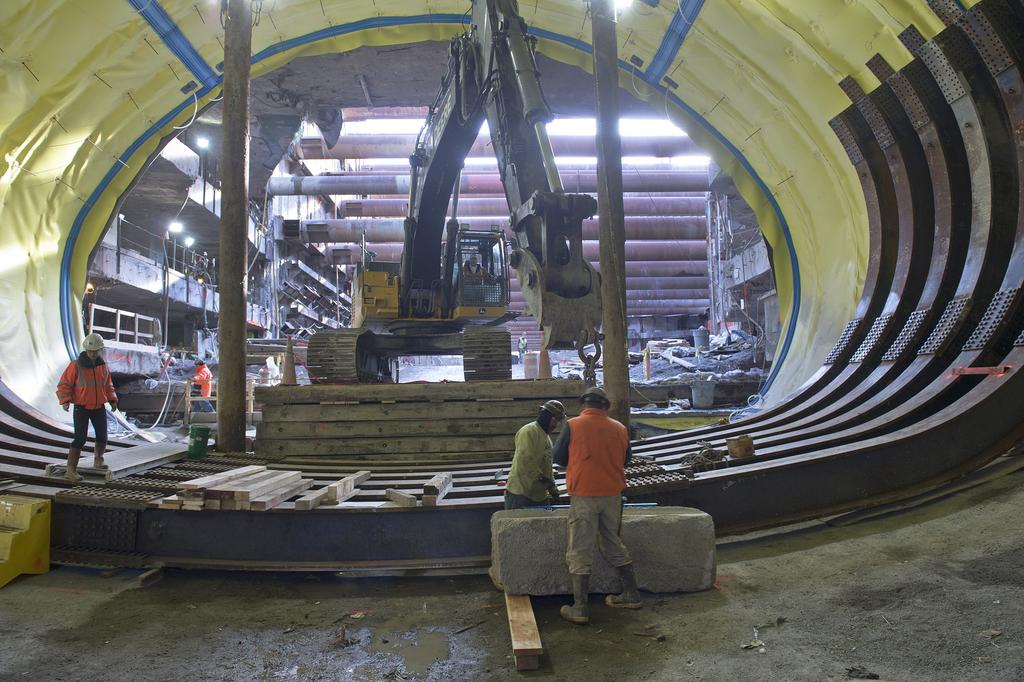What are the people in the foreground of the image doing? The people in the foreground of the image are working. What type of equipment can be seen in the image? There is a machine in the image. What material are the boards in the image made of? The boards in the image are made of wood. Can you describe any other objects in the image? Yes, there are other objects in the image. What is visible in the background of the image? There is a roof in the background of the image. What letter is being used to provide comfort to the people in the image? There is no letter present in the image, and the people are working, not seeking comfort. How many pins are visible on the roof in the background of the image? There are no pins visible on the roof in the background of the image. 